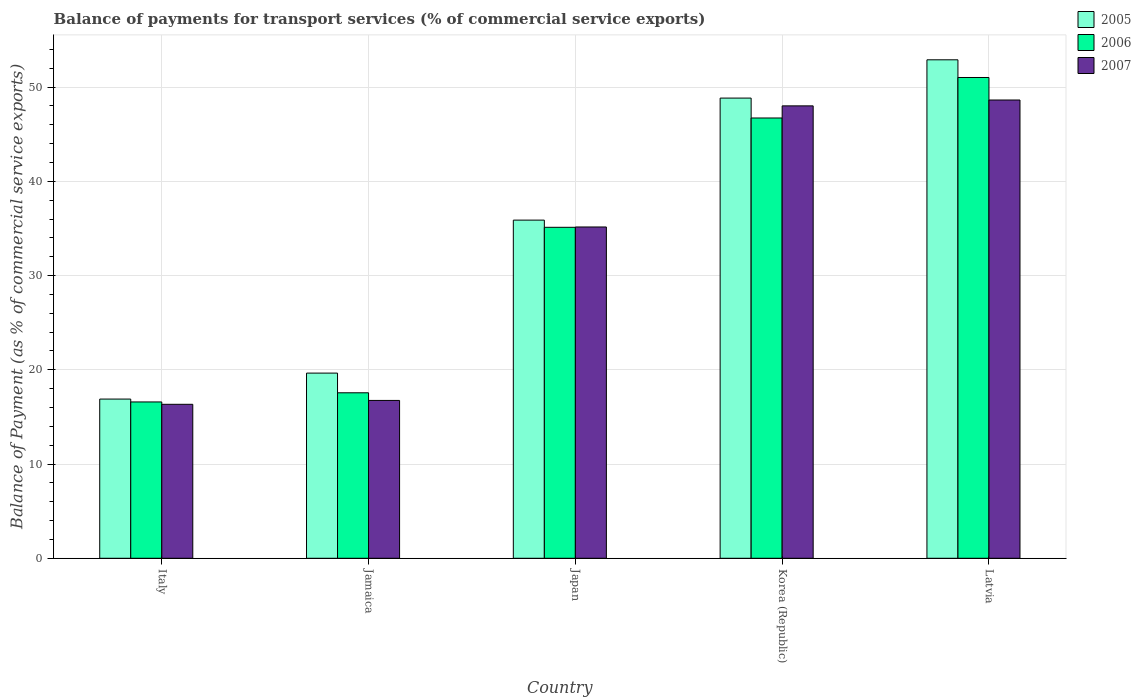How many groups of bars are there?
Provide a short and direct response. 5. How many bars are there on the 1st tick from the left?
Your answer should be very brief. 3. How many bars are there on the 5th tick from the right?
Provide a short and direct response. 3. What is the label of the 5th group of bars from the left?
Offer a terse response. Latvia. What is the balance of payments for transport services in 2006 in Italy?
Provide a short and direct response. 16.59. Across all countries, what is the maximum balance of payments for transport services in 2006?
Give a very brief answer. 51.02. Across all countries, what is the minimum balance of payments for transport services in 2006?
Provide a short and direct response. 16.59. In which country was the balance of payments for transport services in 2005 maximum?
Offer a terse response. Latvia. In which country was the balance of payments for transport services in 2007 minimum?
Make the answer very short. Italy. What is the total balance of payments for transport services in 2005 in the graph?
Make the answer very short. 174.17. What is the difference between the balance of payments for transport services in 2006 in Japan and that in Latvia?
Give a very brief answer. -15.9. What is the difference between the balance of payments for transport services in 2005 in Korea (Republic) and the balance of payments for transport services in 2006 in Jamaica?
Your response must be concise. 31.27. What is the average balance of payments for transport services in 2007 per country?
Offer a terse response. 32.98. What is the difference between the balance of payments for transport services of/in 2005 and balance of payments for transport services of/in 2006 in Korea (Republic)?
Provide a succinct answer. 2.11. What is the ratio of the balance of payments for transport services in 2005 in Korea (Republic) to that in Latvia?
Give a very brief answer. 0.92. Is the balance of payments for transport services in 2006 in Italy less than that in Korea (Republic)?
Make the answer very short. Yes. What is the difference between the highest and the second highest balance of payments for transport services in 2006?
Your response must be concise. -15.9. What is the difference between the highest and the lowest balance of payments for transport services in 2007?
Your answer should be very brief. 32.29. Is the sum of the balance of payments for transport services in 2006 in Jamaica and Latvia greater than the maximum balance of payments for transport services in 2005 across all countries?
Your response must be concise. Yes. Are all the bars in the graph horizontal?
Ensure brevity in your answer.  No. What is the difference between two consecutive major ticks on the Y-axis?
Ensure brevity in your answer.  10. How are the legend labels stacked?
Provide a short and direct response. Vertical. What is the title of the graph?
Provide a short and direct response. Balance of payments for transport services (% of commercial service exports). What is the label or title of the Y-axis?
Ensure brevity in your answer.  Balance of Payment (as % of commercial service exports). What is the Balance of Payment (as % of commercial service exports) of 2005 in Italy?
Ensure brevity in your answer.  16.89. What is the Balance of Payment (as % of commercial service exports) in 2006 in Italy?
Provide a short and direct response. 16.59. What is the Balance of Payment (as % of commercial service exports) of 2007 in Italy?
Keep it short and to the point. 16.34. What is the Balance of Payment (as % of commercial service exports) in 2005 in Jamaica?
Offer a terse response. 19.65. What is the Balance of Payment (as % of commercial service exports) in 2006 in Jamaica?
Offer a very short reply. 17.56. What is the Balance of Payment (as % of commercial service exports) in 2007 in Jamaica?
Offer a terse response. 16.75. What is the Balance of Payment (as % of commercial service exports) of 2005 in Japan?
Provide a succinct answer. 35.89. What is the Balance of Payment (as % of commercial service exports) of 2006 in Japan?
Your response must be concise. 35.12. What is the Balance of Payment (as % of commercial service exports) in 2007 in Japan?
Offer a very short reply. 35.16. What is the Balance of Payment (as % of commercial service exports) in 2005 in Korea (Republic)?
Provide a short and direct response. 48.84. What is the Balance of Payment (as % of commercial service exports) of 2006 in Korea (Republic)?
Give a very brief answer. 46.72. What is the Balance of Payment (as % of commercial service exports) of 2007 in Korea (Republic)?
Your answer should be compact. 48.01. What is the Balance of Payment (as % of commercial service exports) in 2005 in Latvia?
Your response must be concise. 52.9. What is the Balance of Payment (as % of commercial service exports) of 2006 in Latvia?
Ensure brevity in your answer.  51.02. What is the Balance of Payment (as % of commercial service exports) of 2007 in Latvia?
Make the answer very short. 48.63. Across all countries, what is the maximum Balance of Payment (as % of commercial service exports) of 2005?
Provide a short and direct response. 52.9. Across all countries, what is the maximum Balance of Payment (as % of commercial service exports) in 2006?
Give a very brief answer. 51.02. Across all countries, what is the maximum Balance of Payment (as % of commercial service exports) in 2007?
Make the answer very short. 48.63. Across all countries, what is the minimum Balance of Payment (as % of commercial service exports) of 2005?
Ensure brevity in your answer.  16.89. Across all countries, what is the minimum Balance of Payment (as % of commercial service exports) in 2006?
Your answer should be very brief. 16.59. Across all countries, what is the minimum Balance of Payment (as % of commercial service exports) of 2007?
Your answer should be very brief. 16.34. What is the total Balance of Payment (as % of commercial service exports) of 2005 in the graph?
Offer a very short reply. 174.17. What is the total Balance of Payment (as % of commercial service exports) in 2006 in the graph?
Make the answer very short. 167.02. What is the total Balance of Payment (as % of commercial service exports) in 2007 in the graph?
Make the answer very short. 164.89. What is the difference between the Balance of Payment (as % of commercial service exports) in 2005 in Italy and that in Jamaica?
Provide a short and direct response. -2.76. What is the difference between the Balance of Payment (as % of commercial service exports) of 2006 in Italy and that in Jamaica?
Offer a very short reply. -0.97. What is the difference between the Balance of Payment (as % of commercial service exports) in 2007 in Italy and that in Jamaica?
Ensure brevity in your answer.  -0.41. What is the difference between the Balance of Payment (as % of commercial service exports) in 2005 in Italy and that in Japan?
Keep it short and to the point. -18.99. What is the difference between the Balance of Payment (as % of commercial service exports) of 2006 in Italy and that in Japan?
Ensure brevity in your answer.  -18.53. What is the difference between the Balance of Payment (as % of commercial service exports) in 2007 in Italy and that in Japan?
Provide a succinct answer. -18.82. What is the difference between the Balance of Payment (as % of commercial service exports) of 2005 in Italy and that in Korea (Republic)?
Your response must be concise. -31.94. What is the difference between the Balance of Payment (as % of commercial service exports) of 2006 in Italy and that in Korea (Republic)?
Ensure brevity in your answer.  -30.14. What is the difference between the Balance of Payment (as % of commercial service exports) in 2007 in Italy and that in Korea (Republic)?
Your answer should be compact. -31.67. What is the difference between the Balance of Payment (as % of commercial service exports) of 2005 in Italy and that in Latvia?
Provide a succinct answer. -36.01. What is the difference between the Balance of Payment (as % of commercial service exports) in 2006 in Italy and that in Latvia?
Provide a succinct answer. -34.43. What is the difference between the Balance of Payment (as % of commercial service exports) of 2007 in Italy and that in Latvia?
Your response must be concise. -32.29. What is the difference between the Balance of Payment (as % of commercial service exports) of 2005 in Jamaica and that in Japan?
Your answer should be very brief. -16.24. What is the difference between the Balance of Payment (as % of commercial service exports) of 2006 in Jamaica and that in Japan?
Your answer should be very brief. -17.56. What is the difference between the Balance of Payment (as % of commercial service exports) in 2007 in Jamaica and that in Japan?
Give a very brief answer. -18.41. What is the difference between the Balance of Payment (as % of commercial service exports) in 2005 in Jamaica and that in Korea (Republic)?
Offer a very short reply. -29.19. What is the difference between the Balance of Payment (as % of commercial service exports) of 2006 in Jamaica and that in Korea (Republic)?
Give a very brief answer. -29.16. What is the difference between the Balance of Payment (as % of commercial service exports) in 2007 in Jamaica and that in Korea (Republic)?
Provide a short and direct response. -31.26. What is the difference between the Balance of Payment (as % of commercial service exports) in 2005 in Jamaica and that in Latvia?
Offer a very short reply. -33.25. What is the difference between the Balance of Payment (as % of commercial service exports) in 2006 in Jamaica and that in Latvia?
Your response must be concise. -33.46. What is the difference between the Balance of Payment (as % of commercial service exports) of 2007 in Jamaica and that in Latvia?
Ensure brevity in your answer.  -31.88. What is the difference between the Balance of Payment (as % of commercial service exports) in 2005 in Japan and that in Korea (Republic)?
Make the answer very short. -12.95. What is the difference between the Balance of Payment (as % of commercial service exports) in 2006 in Japan and that in Korea (Republic)?
Provide a short and direct response. -11.6. What is the difference between the Balance of Payment (as % of commercial service exports) of 2007 in Japan and that in Korea (Republic)?
Provide a short and direct response. -12.85. What is the difference between the Balance of Payment (as % of commercial service exports) in 2005 in Japan and that in Latvia?
Make the answer very short. -17.01. What is the difference between the Balance of Payment (as % of commercial service exports) in 2006 in Japan and that in Latvia?
Give a very brief answer. -15.9. What is the difference between the Balance of Payment (as % of commercial service exports) in 2007 in Japan and that in Latvia?
Provide a short and direct response. -13.47. What is the difference between the Balance of Payment (as % of commercial service exports) in 2005 in Korea (Republic) and that in Latvia?
Your answer should be compact. -4.06. What is the difference between the Balance of Payment (as % of commercial service exports) of 2006 in Korea (Republic) and that in Latvia?
Make the answer very short. -4.3. What is the difference between the Balance of Payment (as % of commercial service exports) of 2007 in Korea (Republic) and that in Latvia?
Give a very brief answer. -0.62. What is the difference between the Balance of Payment (as % of commercial service exports) of 2005 in Italy and the Balance of Payment (as % of commercial service exports) of 2006 in Jamaica?
Provide a short and direct response. -0.67. What is the difference between the Balance of Payment (as % of commercial service exports) of 2005 in Italy and the Balance of Payment (as % of commercial service exports) of 2007 in Jamaica?
Ensure brevity in your answer.  0.14. What is the difference between the Balance of Payment (as % of commercial service exports) of 2006 in Italy and the Balance of Payment (as % of commercial service exports) of 2007 in Jamaica?
Your answer should be very brief. -0.16. What is the difference between the Balance of Payment (as % of commercial service exports) of 2005 in Italy and the Balance of Payment (as % of commercial service exports) of 2006 in Japan?
Ensure brevity in your answer.  -18.23. What is the difference between the Balance of Payment (as % of commercial service exports) of 2005 in Italy and the Balance of Payment (as % of commercial service exports) of 2007 in Japan?
Provide a succinct answer. -18.26. What is the difference between the Balance of Payment (as % of commercial service exports) in 2006 in Italy and the Balance of Payment (as % of commercial service exports) in 2007 in Japan?
Offer a very short reply. -18.57. What is the difference between the Balance of Payment (as % of commercial service exports) in 2005 in Italy and the Balance of Payment (as % of commercial service exports) in 2006 in Korea (Republic)?
Your answer should be very brief. -29.83. What is the difference between the Balance of Payment (as % of commercial service exports) in 2005 in Italy and the Balance of Payment (as % of commercial service exports) in 2007 in Korea (Republic)?
Provide a succinct answer. -31.12. What is the difference between the Balance of Payment (as % of commercial service exports) in 2006 in Italy and the Balance of Payment (as % of commercial service exports) in 2007 in Korea (Republic)?
Your answer should be compact. -31.42. What is the difference between the Balance of Payment (as % of commercial service exports) in 2005 in Italy and the Balance of Payment (as % of commercial service exports) in 2006 in Latvia?
Offer a terse response. -34.13. What is the difference between the Balance of Payment (as % of commercial service exports) in 2005 in Italy and the Balance of Payment (as % of commercial service exports) in 2007 in Latvia?
Your answer should be very brief. -31.74. What is the difference between the Balance of Payment (as % of commercial service exports) in 2006 in Italy and the Balance of Payment (as % of commercial service exports) in 2007 in Latvia?
Your answer should be very brief. -32.04. What is the difference between the Balance of Payment (as % of commercial service exports) in 2005 in Jamaica and the Balance of Payment (as % of commercial service exports) in 2006 in Japan?
Provide a short and direct response. -15.47. What is the difference between the Balance of Payment (as % of commercial service exports) of 2005 in Jamaica and the Balance of Payment (as % of commercial service exports) of 2007 in Japan?
Give a very brief answer. -15.51. What is the difference between the Balance of Payment (as % of commercial service exports) in 2006 in Jamaica and the Balance of Payment (as % of commercial service exports) in 2007 in Japan?
Provide a succinct answer. -17.6. What is the difference between the Balance of Payment (as % of commercial service exports) in 2005 in Jamaica and the Balance of Payment (as % of commercial service exports) in 2006 in Korea (Republic)?
Ensure brevity in your answer.  -27.07. What is the difference between the Balance of Payment (as % of commercial service exports) in 2005 in Jamaica and the Balance of Payment (as % of commercial service exports) in 2007 in Korea (Republic)?
Give a very brief answer. -28.36. What is the difference between the Balance of Payment (as % of commercial service exports) of 2006 in Jamaica and the Balance of Payment (as % of commercial service exports) of 2007 in Korea (Republic)?
Give a very brief answer. -30.45. What is the difference between the Balance of Payment (as % of commercial service exports) of 2005 in Jamaica and the Balance of Payment (as % of commercial service exports) of 2006 in Latvia?
Ensure brevity in your answer.  -31.37. What is the difference between the Balance of Payment (as % of commercial service exports) in 2005 in Jamaica and the Balance of Payment (as % of commercial service exports) in 2007 in Latvia?
Your answer should be very brief. -28.98. What is the difference between the Balance of Payment (as % of commercial service exports) in 2006 in Jamaica and the Balance of Payment (as % of commercial service exports) in 2007 in Latvia?
Give a very brief answer. -31.07. What is the difference between the Balance of Payment (as % of commercial service exports) of 2005 in Japan and the Balance of Payment (as % of commercial service exports) of 2006 in Korea (Republic)?
Provide a succinct answer. -10.84. What is the difference between the Balance of Payment (as % of commercial service exports) in 2005 in Japan and the Balance of Payment (as % of commercial service exports) in 2007 in Korea (Republic)?
Offer a terse response. -12.12. What is the difference between the Balance of Payment (as % of commercial service exports) in 2006 in Japan and the Balance of Payment (as % of commercial service exports) in 2007 in Korea (Republic)?
Give a very brief answer. -12.89. What is the difference between the Balance of Payment (as % of commercial service exports) of 2005 in Japan and the Balance of Payment (as % of commercial service exports) of 2006 in Latvia?
Give a very brief answer. -15.14. What is the difference between the Balance of Payment (as % of commercial service exports) in 2005 in Japan and the Balance of Payment (as % of commercial service exports) in 2007 in Latvia?
Ensure brevity in your answer.  -12.75. What is the difference between the Balance of Payment (as % of commercial service exports) in 2006 in Japan and the Balance of Payment (as % of commercial service exports) in 2007 in Latvia?
Offer a terse response. -13.51. What is the difference between the Balance of Payment (as % of commercial service exports) of 2005 in Korea (Republic) and the Balance of Payment (as % of commercial service exports) of 2006 in Latvia?
Make the answer very short. -2.19. What is the difference between the Balance of Payment (as % of commercial service exports) of 2005 in Korea (Republic) and the Balance of Payment (as % of commercial service exports) of 2007 in Latvia?
Offer a very short reply. 0.2. What is the difference between the Balance of Payment (as % of commercial service exports) in 2006 in Korea (Republic) and the Balance of Payment (as % of commercial service exports) in 2007 in Latvia?
Your response must be concise. -1.91. What is the average Balance of Payment (as % of commercial service exports) in 2005 per country?
Offer a terse response. 34.83. What is the average Balance of Payment (as % of commercial service exports) in 2006 per country?
Your answer should be very brief. 33.4. What is the average Balance of Payment (as % of commercial service exports) in 2007 per country?
Ensure brevity in your answer.  32.98. What is the difference between the Balance of Payment (as % of commercial service exports) in 2005 and Balance of Payment (as % of commercial service exports) in 2006 in Italy?
Offer a terse response. 0.31. What is the difference between the Balance of Payment (as % of commercial service exports) of 2005 and Balance of Payment (as % of commercial service exports) of 2007 in Italy?
Provide a short and direct response. 0.55. What is the difference between the Balance of Payment (as % of commercial service exports) in 2006 and Balance of Payment (as % of commercial service exports) in 2007 in Italy?
Your response must be concise. 0.25. What is the difference between the Balance of Payment (as % of commercial service exports) of 2005 and Balance of Payment (as % of commercial service exports) of 2006 in Jamaica?
Provide a succinct answer. 2.09. What is the difference between the Balance of Payment (as % of commercial service exports) in 2005 and Balance of Payment (as % of commercial service exports) in 2007 in Jamaica?
Offer a very short reply. 2.9. What is the difference between the Balance of Payment (as % of commercial service exports) in 2006 and Balance of Payment (as % of commercial service exports) in 2007 in Jamaica?
Your answer should be compact. 0.81. What is the difference between the Balance of Payment (as % of commercial service exports) of 2005 and Balance of Payment (as % of commercial service exports) of 2006 in Japan?
Provide a short and direct response. 0.76. What is the difference between the Balance of Payment (as % of commercial service exports) in 2005 and Balance of Payment (as % of commercial service exports) in 2007 in Japan?
Offer a terse response. 0.73. What is the difference between the Balance of Payment (as % of commercial service exports) in 2006 and Balance of Payment (as % of commercial service exports) in 2007 in Japan?
Provide a short and direct response. -0.03. What is the difference between the Balance of Payment (as % of commercial service exports) in 2005 and Balance of Payment (as % of commercial service exports) in 2006 in Korea (Republic)?
Make the answer very short. 2.11. What is the difference between the Balance of Payment (as % of commercial service exports) in 2005 and Balance of Payment (as % of commercial service exports) in 2007 in Korea (Republic)?
Offer a terse response. 0.83. What is the difference between the Balance of Payment (as % of commercial service exports) of 2006 and Balance of Payment (as % of commercial service exports) of 2007 in Korea (Republic)?
Your answer should be very brief. -1.29. What is the difference between the Balance of Payment (as % of commercial service exports) of 2005 and Balance of Payment (as % of commercial service exports) of 2006 in Latvia?
Offer a terse response. 1.88. What is the difference between the Balance of Payment (as % of commercial service exports) in 2005 and Balance of Payment (as % of commercial service exports) in 2007 in Latvia?
Your answer should be very brief. 4.27. What is the difference between the Balance of Payment (as % of commercial service exports) of 2006 and Balance of Payment (as % of commercial service exports) of 2007 in Latvia?
Make the answer very short. 2.39. What is the ratio of the Balance of Payment (as % of commercial service exports) in 2005 in Italy to that in Jamaica?
Your answer should be compact. 0.86. What is the ratio of the Balance of Payment (as % of commercial service exports) of 2006 in Italy to that in Jamaica?
Provide a short and direct response. 0.94. What is the ratio of the Balance of Payment (as % of commercial service exports) in 2007 in Italy to that in Jamaica?
Your answer should be very brief. 0.98. What is the ratio of the Balance of Payment (as % of commercial service exports) of 2005 in Italy to that in Japan?
Ensure brevity in your answer.  0.47. What is the ratio of the Balance of Payment (as % of commercial service exports) of 2006 in Italy to that in Japan?
Keep it short and to the point. 0.47. What is the ratio of the Balance of Payment (as % of commercial service exports) in 2007 in Italy to that in Japan?
Provide a short and direct response. 0.46. What is the ratio of the Balance of Payment (as % of commercial service exports) of 2005 in Italy to that in Korea (Republic)?
Your answer should be very brief. 0.35. What is the ratio of the Balance of Payment (as % of commercial service exports) of 2006 in Italy to that in Korea (Republic)?
Provide a succinct answer. 0.35. What is the ratio of the Balance of Payment (as % of commercial service exports) in 2007 in Italy to that in Korea (Republic)?
Make the answer very short. 0.34. What is the ratio of the Balance of Payment (as % of commercial service exports) of 2005 in Italy to that in Latvia?
Provide a short and direct response. 0.32. What is the ratio of the Balance of Payment (as % of commercial service exports) of 2006 in Italy to that in Latvia?
Provide a short and direct response. 0.33. What is the ratio of the Balance of Payment (as % of commercial service exports) of 2007 in Italy to that in Latvia?
Your response must be concise. 0.34. What is the ratio of the Balance of Payment (as % of commercial service exports) of 2005 in Jamaica to that in Japan?
Give a very brief answer. 0.55. What is the ratio of the Balance of Payment (as % of commercial service exports) in 2007 in Jamaica to that in Japan?
Your answer should be compact. 0.48. What is the ratio of the Balance of Payment (as % of commercial service exports) in 2005 in Jamaica to that in Korea (Republic)?
Your answer should be compact. 0.4. What is the ratio of the Balance of Payment (as % of commercial service exports) of 2006 in Jamaica to that in Korea (Republic)?
Your answer should be very brief. 0.38. What is the ratio of the Balance of Payment (as % of commercial service exports) of 2007 in Jamaica to that in Korea (Republic)?
Make the answer very short. 0.35. What is the ratio of the Balance of Payment (as % of commercial service exports) in 2005 in Jamaica to that in Latvia?
Provide a succinct answer. 0.37. What is the ratio of the Balance of Payment (as % of commercial service exports) in 2006 in Jamaica to that in Latvia?
Keep it short and to the point. 0.34. What is the ratio of the Balance of Payment (as % of commercial service exports) of 2007 in Jamaica to that in Latvia?
Ensure brevity in your answer.  0.34. What is the ratio of the Balance of Payment (as % of commercial service exports) of 2005 in Japan to that in Korea (Republic)?
Your answer should be compact. 0.73. What is the ratio of the Balance of Payment (as % of commercial service exports) of 2006 in Japan to that in Korea (Republic)?
Offer a very short reply. 0.75. What is the ratio of the Balance of Payment (as % of commercial service exports) of 2007 in Japan to that in Korea (Republic)?
Ensure brevity in your answer.  0.73. What is the ratio of the Balance of Payment (as % of commercial service exports) of 2005 in Japan to that in Latvia?
Offer a very short reply. 0.68. What is the ratio of the Balance of Payment (as % of commercial service exports) of 2006 in Japan to that in Latvia?
Offer a very short reply. 0.69. What is the ratio of the Balance of Payment (as % of commercial service exports) of 2007 in Japan to that in Latvia?
Keep it short and to the point. 0.72. What is the ratio of the Balance of Payment (as % of commercial service exports) in 2005 in Korea (Republic) to that in Latvia?
Give a very brief answer. 0.92. What is the ratio of the Balance of Payment (as % of commercial service exports) in 2006 in Korea (Republic) to that in Latvia?
Provide a succinct answer. 0.92. What is the ratio of the Balance of Payment (as % of commercial service exports) in 2007 in Korea (Republic) to that in Latvia?
Your response must be concise. 0.99. What is the difference between the highest and the second highest Balance of Payment (as % of commercial service exports) in 2005?
Offer a terse response. 4.06. What is the difference between the highest and the second highest Balance of Payment (as % of commercial service exports) in 2006?
Provide a short and direct response. 4.3. What is the difference between the highest and the second highest Balance of Payment (as % of commercial service exports) in 2007?
Your answer should be compact. 0.62. What is the difference between the highest and the lowest Balance of Payment (as % of commercial service exports) in 2005?
Keep it short and to the point. 36.01. What is the difference between the highest and the lowest Balance of Payment (as % of commercial service exports) of 2006?
Your answer should be compact. 34.43. What is the difference between the highest and the lowest Balance of Payment (as % of commercial service exports) in 2007?
Your answer should be compact. 32.29. 